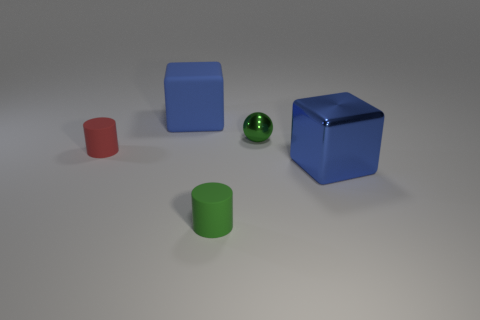Add 1 large cubes. How many objects exist? 6 Subtract all blocks. How many objects are left? 3 Add 2 small purple metal things. How many small purple metal things exist? 2 Subtract 0 red balls. How many objects are left? 5 Subtract all shiny cubes. Subtract all tiny green objects. How many objects are left? 2 Add 1 small shiny objects. How many small shiny objects are left? 2 